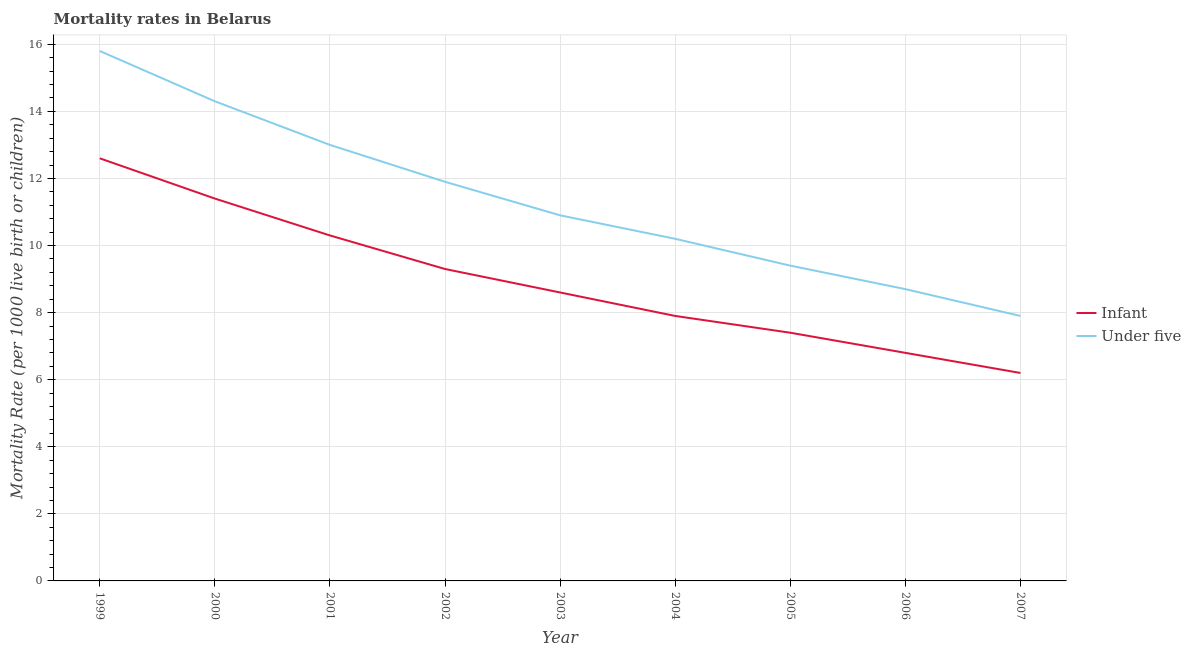How many different coloured lines are there?
Offer a very short reply. 2. Is the number of lines equal to the number of legend labels?
Make the answer very short. Yes. What is the under-5 mortality rate in 2004?
Your response must be concise. 10.2. Across all years, what is the maximum under-5 mortality rate?
Make the answer very short. 15.8. In which year was the under-5 mortality rate maximum?
Provide a succinct answer. 1999. In which year was the under-5 mortality rate minimum?
Provide a short and direct response. 2007. What is the total infant mortality rate in the graph?
Give a very brief answer. 80.5. What is the difference between the under-5 mortality rate in 1999 and that in 2001?
Provide a succinct answer. 2.8. What is the difference between the infant mortality rate in 2003 and the under-5 mortality rate in 2000?
Provide a succinct answer. -5.7. What is the average under-5 mortality rate per year?
Give a very brief answer. 11.34. In the year 2001, what is the difference between the infant mortality rate and under-5 mortality rate?
Offer a very short reply. -2.7. In how many years, is the under-5 mortality rate greater than 4.4?
Ensure brevity in your answer.  9. What is the ratio of the under-5 mortality rate in 2002 to that in 2007?
Offer a terse response. 1.51. Is the sum of the infant mortality rate in 2001 and 2007 greater than the maximum under-5 mortality rate across all years?
Make the answer very short. Yes. Does the under-5 mortality rate monotonically increase over the years?
Offer a terse response. No. How many lines are there?
Provide a succinct answer. 2. How many years are there in the graph?
Offer a very short reply. 9. What is the difference between two consecutive major ticks on the Y-axis?
Your response must be concise. 2. Are the values on the major ticks of Y-axis written in scientific E-notation?
Keep it short and to the point. No. Does the graph contain any zero values?
Ensure brevity in your answer.  No. Where does the legend appear in the graph?
Make the answer very short. Center right. How many legend labels are there?
Your answer should be compact. 2. What is the title of the graph?
Offer a very short reply. Mortality rates in Belarus. What is the label or title of the X-axis?
Give a very brief answer. Year. What is the label or title of the Y-axis?
Ensure brevity in your answer.  Mortality Rate (per 1000 live birth or children). What is the Mortality Rate (per 1000 live birth or children) in Under five in 1999?
Ensure brevity in your answer.  15.8. What is the Mortality Rate (per 1000 live birth or children) of Infant in 2001?
Make the answer very short. 10.3. What is the Mortality Rate (per 1000 live birth or children) of Infant in 2003?
Provide a short and direct response. 8.6. What is the Mortality Rate (per 1000 live birth or children) of Under five in 2003?
Ensure brevity in your answer.  10.9. What is the Mortality Rate (per 1000 live birth or children) in Under five in 2005?
Your response must be concise. 9.4. What is the Mortality Rate (per 1000 live birth or children) of Under five in 2006?
Keep it short and to the point. 8.7. What is the Mortality Rate (per 1000 live birth or children) in Infant in 2007?
Offer a very short reply. 6.2. Across all years, what is the maximum Mortality Rate (per 1000 live birth or children) of Infant?
Give a very brief answer. 12.6. Across all years, what is the maximum Mortality Rate (per 1000 live birth or children) in Under five?
Offer a very short reply. 15.8. What is the total Mortality Rate (per 1000 live birth or children) in Infant in the graph?
Your answer should be very brief. 80.5. What is the total Mortality Rate (per 1000 live birth or children) in Under five in the graph?
Give a very brief answer. 102.1. What is the difference between the Mortality Rate (per 1000 live birth or children) in Infant in 1999 and that in 2000?
Offer a very short reply. 1.2. What is the difference between the Mortality Rate (per 1000 live birth or children) of Infant in 1999 and that in 2001?
Your answer should be compact. 2.3. What is the difference between the Mortality Rate (per 1000 live birth or children) in Under five in 1999 and that in 2003?
Keep it short and to the point. 4.9. What is the difference between the Mortality Rate (per 1000 live birth or children) in Under five in 1999 and that in 2004?
Make the answer very short. 5.6. What is the difference between the Mortality Rate (per 1000 live birth or children) in Infant in 1999 and that in 2006?
Provide a succinct answer. 5.8. What is the difference between the Mortality Rate (per 1000 live birth or children) of Under five in 1999 and that in 2006?
Provide a succinct answer. 7.1. What is the difference between the Mortality Rate (per 1000 live birth or children) of Infant in 2000 and that in 2001?
Offer a very short reply. 1.1. What is the difference between the Mortality Rate (per 1000 live birth or children) of Infant in 2000 and that in 2002?
Your answer should be very brief. 2.1. What is the difference between the Mortality Rate (per 1000 live birth or children) in Under five in 2000 and that in 2003?
Your response must be concise. 3.4. What is the difference between the Mortality Rate (per 1000 live birth or children) of Infant in 2000 and that in 2004?
Offer a terse response. 3.5. What is the difference between the Mortality Rate (per 1000 live birth or children) of Infant in 2000 and that in 2006?
Ensure brevity in your answer.  4.6. What is the difference between the Mortality Rate (per 1000 live birth or children) in Under five in 2001 and that in 2002?
Your answer should be compact. 1.1. What is the difference between the Mortality Rate (per 1000 live birth or children) in Under five in 2001 and that in 2004?
Offer a very short reply. 2.8. What is the difference between the Mortality Rate (per 1000 live birth or children) of Infant in 2001 and that in 2006?
Give a very brief answer. 3.5. What is the difference between the Mortality Rate (per 1000 live birth or children) in Under five in 2001 and that in 2006?
Provide a short and direct response. 4.3. What is the difference between the Mortality Rate (per 1000 live birth or children) in Under five in 2001 and that in 2007?
Give a very brief answer. 5.1. What is the difference between the Mortality Rate (per 1000 live birth or children) in Under five in 2002 and that in 2003?
Give a very brief answer. 1. What is the difference between the Mortality Rate (per 1000 live birth or children) of Under five in 2002 and that in 2004?
Make the answer very short. 1.7. What is the difference between the Mortality Rate (per 1000 live birth or children) of Under five in 2002 and that in 2006?
Offer a terse response. 3.2. What is the difference between the Mortality Rate (per 1000 live birth or children) in Under five in 2002 and that in 2007?
Ensure brevity in your answer.  4. What is the difference between the Mortality Rate (per 1000 live birth or children) of Infant in 2003 and that in 2004?
Make the answer very short. 0.7. What is the difference between the Mortality Rate (per 1000 live birth or children) in Infant in 2003 and that in 2005?
Provide a succinct answer. 1.2. What is the difference between the Mortality Rate (per 1000 live birth or children) in Under five in 2003 and that in 2005?
Your answer should be very brief. 1.5. What is the difference between the Mortality Rate (per 1000 live birth or children) in Infant in 2003 and that in 2007?
Your response must be concise. 2.4. What is the difference between the Mortality Rate (per 1000 live birth or children) in Infant in 2004 and that in 2005?
Your response must be concise. 0.5. What is the difference between the Mortality Rate (per 1000 live birth or children) of Infant in 2004 and that in 2007?
Give a very brief answer. 1.7. What is the difference between the Mortality Rate (per 1000 live birth or children) in Infant in 2005 and that in 2006?
Offer a very short reply. 0.6. What is the difference between the Mortality Rate (per 1000 live birth or children) in Infant in 2005 and that in 2007?
Your answer should be very brief. 1.2. What is the difference between the Mortality Rate (per 1000 live birth or children) of Infant in 2006 and that in 2007?
Give a very brief answer. 0.6. What is the difference between the Mortality Rate (per 1000 live birth or children) of Under five in 2006 and that in 2007?
Your answer should be compact. 0.8. What is the difference between the Mortality Rate (per 1000 live birth or children) in Infant in 1999 and the Mortality Rate (per 1000 live birth or children) in Under five in 2000?
Ensure brevity in your answer.  -1.7. What is the difference between the Mortality Rate (per 1000 live birth or children) in Infant in 1999 and the Mortality Rate (per 1000 live birth or children) in Under five in 2003?
Your answer should be very brief. 1.7. What is the difference between the Mortality Rate (per 1000 live birth or children) of Infant in 1999 and the Mortality Rate (per 1000 live birth or children) of Under five in 2006?
Your response must be concise. 3.9. What is the difference between the Mortality Rate (per 1000 live birth or children) of Infant in 2000 and the Mortality Rate (per 1000 live birth or children) of Under five in 2001?
Ensure brevity in your answer.  -1.6. What is the difference between the Mortality Rate (per 1000 live birth or children) of Infant in 2000 and the Mortality Rate (per 1000 live birth or children) of Under five in 2002?
Give a very brief answer. -0.5. What is the difference between the Mortality Rate (per 1000 live birth or children) in Infant in 2000 and the Mortality Rate (per 1000 live birth or children) in Under five in 2003?
Give a very brief answer. 0.5. What is the difference between the Mortality Rate (per 1000 live birth or children) of Infant in 2000 and the Mortality Rate (per 1000 live birth or children) of Under five in 2005?
Keep it short and to the point. 2. What is the difference between the Mortality Rate (per 1000 live birth or children) of Infant in 2000 and the Mortality Rate (per 1000 live birth or children) of Under five in 2006?
Keep it short and to the point. 2.7. What is the difference between the Mortality Rate (per 1000 live birth or children) in Infant in 2000 and the Mortality Rate (per 1000 live birth or children) in Under five in 2007?
Your answer should be compact. 3.5. What is the difference between the Mortality Rate (per 1000 live birth or children) of Infant in 2001 and the Mortality Rate (per 1000 live birth or children) of Under five in 2005?
Offer a very short reply. 0.9. What is the difference between the Mortality Rate (per 1000 live birth or children) of Infant in 2001 and the Mortality Rate (per 1000 live birth or children) of Under five in 2007?
Make the answer very short. 2.4. What is the difference between the Mortality Rate (per 1000 live birth or children) in Infant in 2002 and the Mortality Rate (per 1000 live birth or children) in Under five in 2003?
Your response must be concise. -1.6. What is the difference between the Mortality Rate (per 1000 live birth or children) in Infant in 2002 and the Mortality Rate (per 1000 live birth or children) in Under five in 2005?
Your response must be concise. -0.1. What is the difference between the Mortality Rate (per 1000 live birth or children) of Infant in 2002 and the Mortality Rate (per 1000 live birth or children) of Under five in 2007?
Keep it short and to the point. 1.4. What is the difference between the Mortality Rate (per 1000 live birth or children) in Infant in 2003 and the Mortality Rate (per 1000 live birth or children) in Under five in 2004?
Provide a short and direct response. -1.6. What is the difference between the Mortality Rate (per 1000 live birth or children) of Infant in 2003 and the Mortality Rate (per 1000 live birth or children) of Under five in 2005?
Provide a succinct answer. -0.8. What is the difference between the Mortality Rate (per 1000 live birth or children) of Infant in 2004 and the Mortality Rate (per 1000 live birth or children) of Under five in 2006?
Your answer should be compact. -0.8. What is the difference between the Mortality Rate (per 1000 live birth or children) in Infant in 2004 and the Mortality Rate (per 1000 live birth or children) in Under five in 2007?
Ensure brevity in your answer.  0. What is the difference between the Mortality Rate (per 1000 live birth or children) in Infant in 2005 and the Mortality Rate (per 1000 live birth or children) in Under five in 2006?
Provide a short and direct response. -1.3. What is the difference between the Mortality Rate (per 1000 live birth or children) in Infant in 2005 and the Mortality Rate (per 1000 live birth or children) in Under five in 2007?
Keep it short and to the point. -0.5. What is the average Mortality Rate (per 1000 live birth or children) in Infant per year?
Make the answer very short. 8.94. What is the average Mortality Rate (per 1000 live birth or children) of Under five per year?
Give a very brief answer. 11.34. In the year 1999, what is the difference between the Mortality Rate (per 1000 live birth or children) in Infant and Mortality Rate (per 1000 live birth or children) in Under five?
Your answer should be very brief. -3.2. In the year 2001, what is the difference between the Mortality Rate (per 1000 live birth or children) in Infant and Mortality Rate (per 1000 live birth or children) in Under five?
Your answer should be compact. -2.7. In the year 2003, what is the difference between the Mortality Rate (per 1000 live birth or children) in Infant and Mortality Rate (per 1000 live birth or children) in Under five?
Make the answer very short. -2.3. In the year 2007, what is the difference between the Mortality Rate (per 1000 live birth or children) of Infant and Mortality Rate (per 1000 live birth or children) of Under five?
Keep it short and to the point. -1.7. What is the ratio of the Mortality Rate (per 1000 live birth or children) in Infant in 1999 to that in 2000?
Your answer should be very brief. 1.11. What is the ratio of the Mortality Rate (per 1000 live birth or children) in Under five in 1999 to that in 2000?
Keep it short and to the point. 1.1. What is the ratio of the Mortality Rate (per 1000 live birth or children) of Infant in 1999 to that in 2001?
Offer a terse response. 1.22. What is the ratio of the Mortality Rate (per 1000 live birth or children) of Under five in 1999 to that in 2001?
Your response must be concise. 1.22. What is the ratio of the Mortality Rate (per 1000 live birth or children) of Infant in 1999 to that in 2002?
Provide a succinct answer. 1.35. What is the ratio of the Mortality Rate (per 1000 live birth or children) of Under five in 1999 to that in 2002?
Your answer should be very brief. 1.33. What is the ratio of the Mortality Rate (per 1000 live birth or children) in Infant in 1999 to that in 2003?
Your response must be concise. 1.47. What is the ratio of the Mortality Rate (per 1000 live birth or children) in Under five in 1999 to that in 2003?
Offer a very short reply. 1.45. What is the ratio of the Mortality Rate (per 1000 live birth or children) in Infant in 1999 to that in 2004?
Give a very brief answer. 1.59. What is the ratio of the Mortality Rate (per 1000 live birth or children) of Under five in 1999 to that in 2004?
Ensure brevity in your answer.  1.55. What is the ratio of the Mortality Rate (per 1000 live birth or children) in Infant in 1999 to that in 2005?
Your answer should be compact. 1.7. What is the ratio of the Mortality Rate (per 1000 live birth or children) of Under five in 1999 to that in 2005?
Your answer should be compact. 1.68. What is the ratio of the Mortality Rate (per 1000 live birth or children) in Infant in 1999 to that in 2006?
Make the answer very short. 1.85. What is the ratio of the Mortality Rate (per 1000 live birth or children) of Under five in 1999 to that in 2006?
Offer a very short reply. 1.82. What is the ratio of the Mortality Rate (per 1000 live birth or children) of Infant in 1999 to that in 2007?
Keep it short and to the point. 2.03. What is the ratio of the Mortality Rate (per 1000 live birth or children) of Infant in 2000 to that in 2001?
Make the answer very short. 1.11. What is the ratio of the Mortality Rate (per 1000 live birth or children) of Under five in 2000 to that in 2001?
Provide a succinct answer. 1.1. What is the ratio of the Mortality Rate (per 1000 live birth or children) in Infant in 2000 to that in 2002?
Your response must be concise. 1.23. What is the ratio of the Mortality Rate (per 1000 live birth or children) in Under five in 2000 to that in 2002?
Offer a terse response. 1.2. What is the ratio of the Mortality Rate (per 1000 live birth or children) in Infant in 2000 to that in 2003?
Provide a short and direct response. 1.33. What is the ratio of the Mortality Rate (per 1000 live birth or children) of Under five in 2000 to that in 2003?
Make the answer very short. 1.31. What is the ratio of the Mortality Rate (per 1000 live birth or children) in Infant in 2000 to that in 2004?
Provide a short and direct response. 1.44. What is the ratio of the Mortality Rate (per 1000 live birth or children) in Under five in 2000 to that in 2004?
Offer a terse response. 1.4. What is the ratio of the Mortality Rate (per 1000 live birth or children) of Infant in 2000 to that in 2005?
Your response must be concise. 1.54. What is the ratio of the Mortality Rate (per 1000 live birth or children) in Under five in 2000 to that in 2005?
Offer a very short reply. 1.52. What is the ratio of the Mortality Rate (per 1000 live birth or children) in Infant in 2000 to that in 2006?
Your answer should be compact. 1.68. What is the ratio of the Mortality Rate (per 1000 live birth or children) in Under five in 2000 to that in 2006?
Keep it short and to the point. 1.64. What is the ratio of the Mortality Rate (per 1000 live birth or children) in Infant in 2000 to that in 2007?
Make the answer very short. 1.84. What is the ratio of the Mortality Rate (per 1000 live birth or children) in Under five in 2000 to that in 2007?
Offer a terse response. 1.81. What is the ratio of the Mortality Rate (per 1000 live birth or children) in Infant in 2001 to that in 2002?
Your answer should be compact. 1.11. What is the ratio of the Mortality Rate (per 1000 live birth or children) of Under five in 2001 to that in 2002?
Your answer should be compact. 1.09. What is the ratio of the Mortality Rate (per 1000 live birth or children) in Infant in 2001 to that in 2003?
Provide a succinct answer. 1.2. What is the ratio of the Mortality Rate (per 1000 live birth or children) of Under five in 2001 to that in 2003?
Keep it short and to the point. 1.19. What is the ratio of the Mortality Rate (per 1000 live birth or children) in Infant in 2001 to that in 2004?
Your answer should be compact. 1.3. What is the ratio of the Mortality Rate (per 1000 live birth or children) of Under five in 2001 to that in 2004?
Your response must be concise. 1.27. What is the ratio of the Mortality Rate (per 1000 live birth or children) of Infant in 2001 to that in 2005?
Make the answer very short. 1.39. What is the ratio of the Mortality Rate (per 1000 live birth or children) of Under five in 2001 to that in 2005?
Offer a terse response. 1.38. What is the ratio of the Mortality Rate (per 1000 live birth or children) of Infant in 2001 to that in 2006?
Your answer should be compact. 1.51. What is the ratio of the Mortality Rate (per 1000 live birth or children) of Under five in 2001 to that in 2006?
Provide a succinct answer. 1.49. What is the ratio of the Mortality Rate (per 1000 live birth or children) of Infant in 2001 to that in 2007?
Provide a short and direct response. 1.66. What is the ratio of the Mortality Rate (per 1000 live birth or children) in Under five in 2001 to that in 2007?
Offer a terse response. 1.65. What is the ratio of the Mortality Rate (per 1000 live birth or children) of Infant in 2002 to that in 2003?
Your answer should be very brief. 1.08. What is the ratio of the Mortality Rate (per 1000 live birth or children) of Under five in 2002 to that in 2003?
Provide a succinct answer. 1.09. What is the ratio of the Mortality Rate (per 1000 live birth or children) of Infant in 2002 to that in 2004?
Your response must be concise. 1.18. What is the ratio of the Mortality Rate (per 1000 live birth or children) in Under five in 2002 to that in 2004?
Ensure brevity in your answer.  1.17. What is the ratio of the Mortality Rate (per 1000 live birth or children) in Infant in 2002 to that in 2005?
Make the answer very short. 1.26. What is the ratio of the Mortality Rate (per 1000 live birth or children) of Under five in 2002 to that in 2005?
Provide a short and direct response. 1.27. What is the ratio of the Mortality Rate (per 1000 live birth or children) of Infant in 2002 to that in 2006?
Provide a succinct answer. 1.37. What is the ratio of the Mortality Rate (per 1000 live birth or children) of Under five in 2002 to that in 2006?
Provide a short and direct response. 1.37. What is the ratio of the Mortality Rate (per 1000 live birth or children) in Infant in 2002 to that in 2007?
Your answer should be compact. 1.5. What is the ratio of the Mortality Rate (per 1000 live birth or children) of Under five in 2002 to that in 2007?
Ensure brevity in your answer.  1.51. What is the ratio of the Mortality Rate (per 1000 live birth or children) in Infant in 2003 to that in 2004?
Give a very brief answer. 1.09. What is the ratio of the Mortality Rate (per 1000 live birth or children) in Under five in 2003 to that in 2004?
Your answer should be very brief. 1.07. What is the ratio of the Mortality Rate (per 1000 live birth or children) of Infant in 2003 to that in 2005?
Your response must be concise. 1.16. What is the ratio of the Mortality Rate (per 1000 live birth or children) of Under five in 2003 to that in 2005?
Provide a short and direct response. 1.16. What is the ratio of the Mortality Rate (per 1000 live birth or children) in Infant in 2003 to that in 2006?
Your response must be concise. 1.26. What is the ratio of the Mortality Rate (per 1000 live birth or children) in Under five in 2003 to that in 2006?
Provide a short and direct response. 1.25. What is the ratio of the Mortality Rate (per 1000 live birth or children) in Infant in 2003 to that in 2007?
Make the answer very short. 1.39. What is the ratio of the Mortality Rate (per 1000 live birth or children) of Under five in 2003 to that in 2007?
Offer a very short reply. 1.38. What is the ratio of the Mortality Rate (per 1000 live birth or children) of Infant in 2004 to that in 2005?
Make the answer very short. 1.07. What is the ratio of the Mortality Rate (per 1000 live birth or children) of Under five in 2004 to that in 2005?
Ensure brevity in your answer.  1.09. What is the ratio of the Mortality Rate (per 1000 live birth or children) in Infant in 2004 to that in 2006?
Provide a succinct answer. 1.16. What is the ratio of the Mortality Rate (per 1000 live birth or children) in Under five in 2004 to that in 2006?
Make the answer very short. 1.17. What is the ratio of the Mortality Rate (per 1000 live birth or children) in Infant in 2004 to that in 2007?
Offer a terse response. 1.27. What is the ratio of the Mortality Rate (per 1000 live birth or children) of Under five in 2004 to that in 2007?
Keep it short and to the point. 1.29. What is the ratio of the Mortality Rate (per 1000 live birth or children) of Infant in 2005 to that in 2006?
Your answer should be compact. 1.09. What is the ratio of the Mortality Rate (per 1000 live birth or children) in Under five in 2005 to that in 2006?
Your answer should be compact. 1.08. What is the ratio of the Mortality Rate (per 1000 live birth or children) in Infant in 2005 to that in 2007?
Ensure brevity in your answer.  1.19. What is the ratio of the Mortality Rate (per 1000 live birth or children) of Under five in 2005 to that in 2007?
Make the answer very short. 1.19. What is the ratio of the Mortality Rate (per 1000 live birth or children) of Infant in 2006 to that in 2007?
Offer a terse response. 1.1. What is the ratio of the Mortality Rate (per 1000 live birth or children) of Under five in 2006 to that in 2007?
Your answer should be very brief. 1.1. What is the difference between the highest and the lowest Mortality Rate (per 1000 live birth or children) in Infant?
Your answer should be compact. 6.4. What is the difference between the highest and the lowest Mortality Rate (per 1000 live birth or children) of Under five?
Provide a short and direct response. 7.9. 